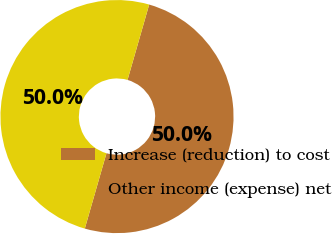Convert chart. <chart><loc_0><loc_0><loc_500><loc_500><pie_chart><fcel>Increase (reduction) to cost<fcel>Other income (expense) net<nl><fcel>50.0%<fcel>50.0%<nl></chart> 